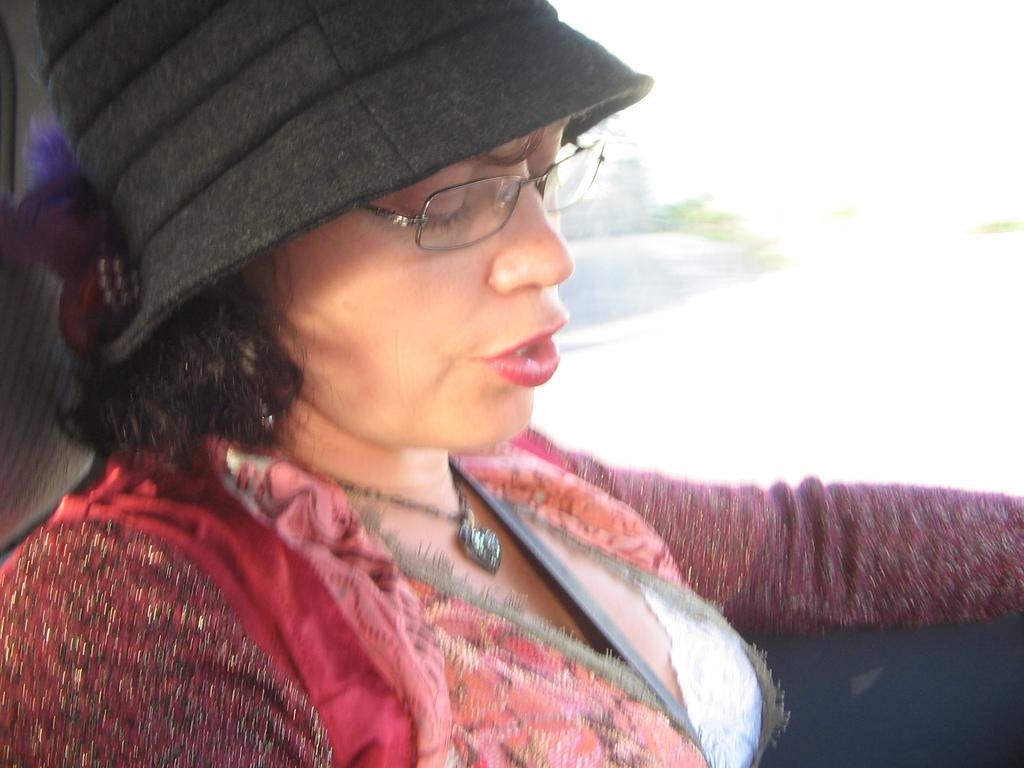Who is the main subject in the image? There is a lady in the image. What is the lady wearing on her upper body? The lady is wearing a pink jacket. What type of headwear is the lady wearing? The lady is wearing a black cap. Where is the lady sitting in the image? The lady is sitting on a car seat. What type of rifle is the lady holding in the image? There is no rifle present in the image; the lady is only wearing a pink jacket and a black cap while sitting on a car seat. 